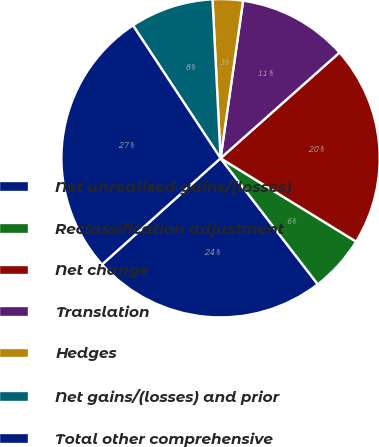Convert chart. <chart><loc_0><loc_0><loc_500><loc_500><pie_chart><fcel>Net unrealized gains/(losses)<fcel>Reclassification adjustment<fcel>Net change<fcel>Translation<fcel>Hedges<fcel>Net gains/(losses) and prior<fcel>Total other comprehensive<nl><fcel>23.83%<fcel>5.77%<fcel>20.34%<fcel>11.17%<fcel>3.07%<fcel>8.47%<fcel>27.35%<nl></chart> 